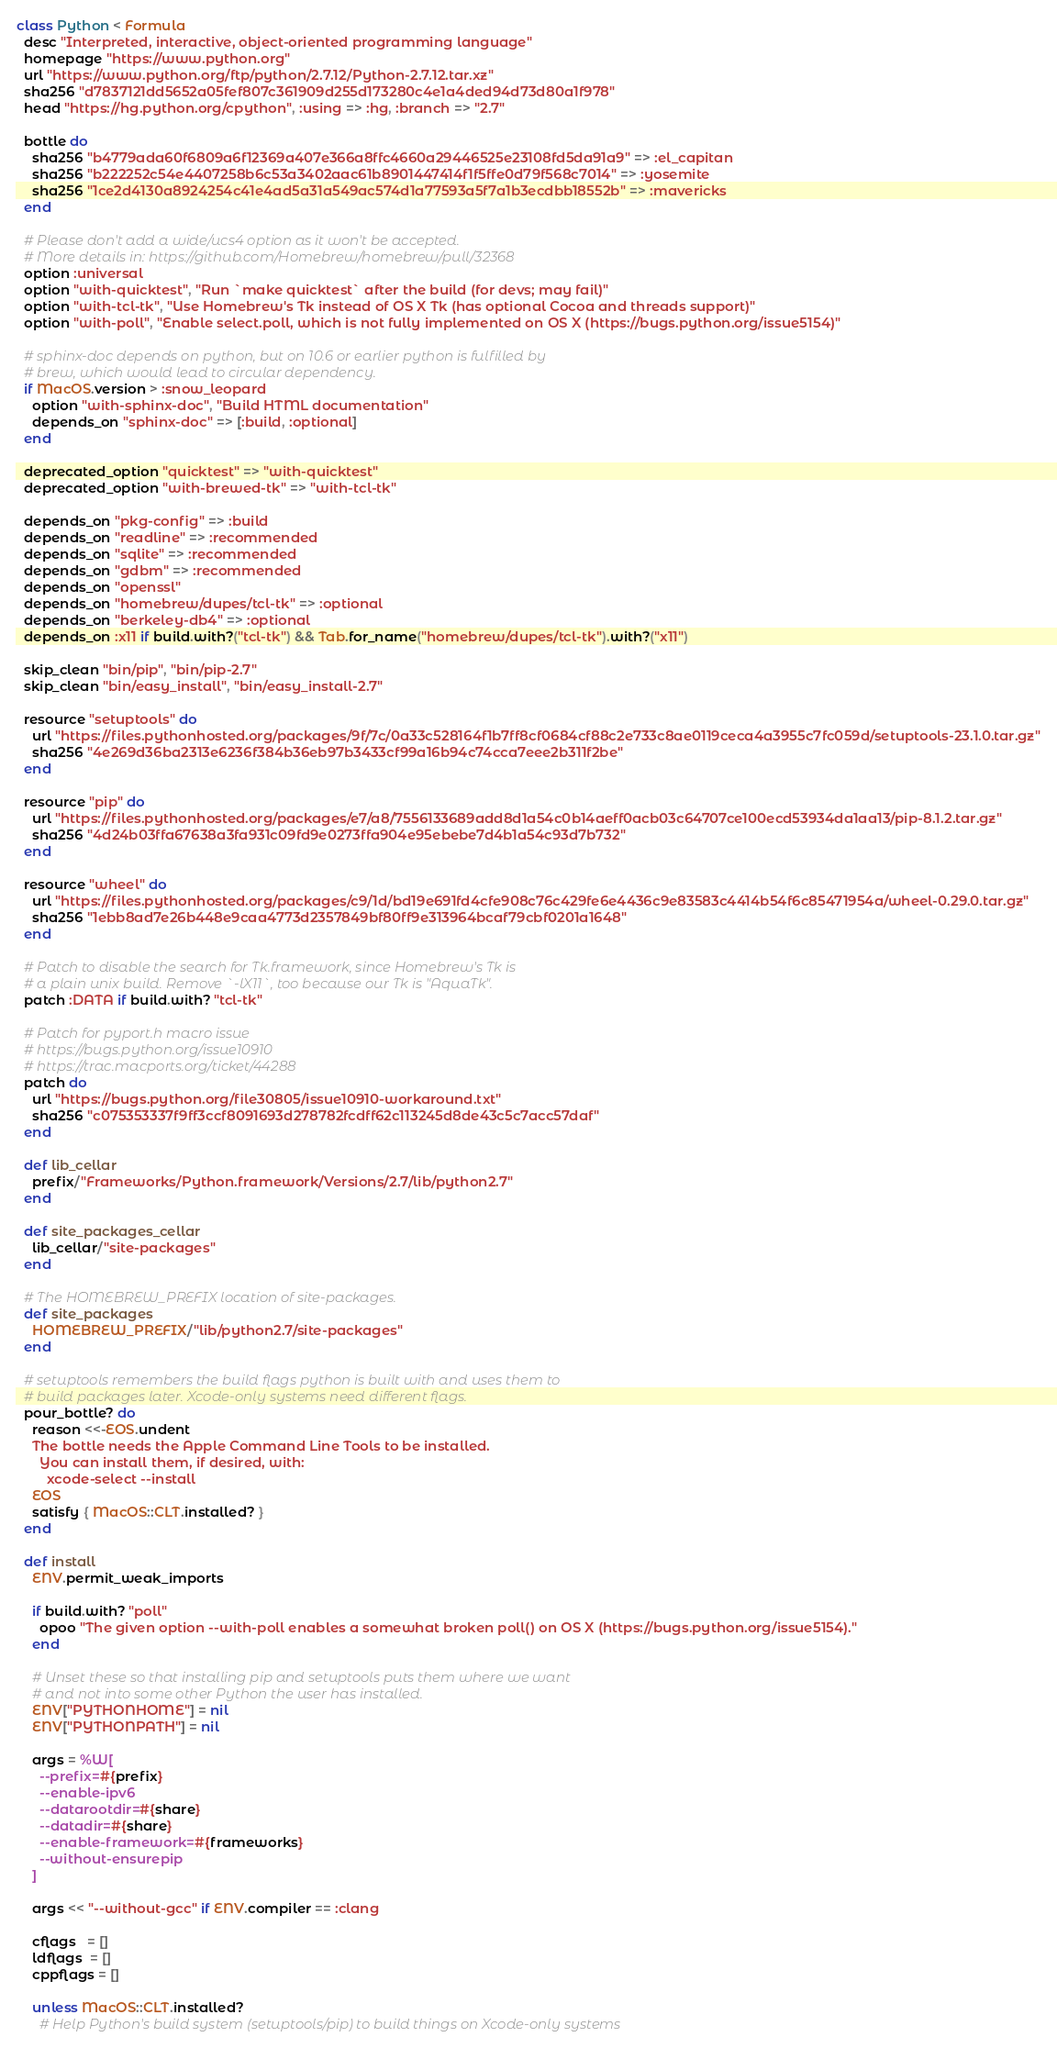Convert code to text. <code><loc_0><loc_0><loc_500><loc_500><_Ruby_>class Python < Formula
  desc "Interpreted, interactive, object-oriented programming language"
  homepage "https://www.python.org"
  url "https://www.python.org/ftp/python/2.7.12/Python-2.7.12.tar.xz"
  sha256 "d7837121dd5652a05fef807c361909d255d173280c4e1a4ded94d73d80a1f978"
  head "https://hg.python.org/cpython", :using => :hg, :branch => "2.7"

  bottle do
    sha256 "b4779ada60f6809a6f12369a407e366a8ffc4660a29446525e23108fd5da91a9" => :el_capitan
    sha256 "b222252c54e4407258b6c53a3402aac61b8901447414f1f5ffe0d79f568c7014" => :yosemite
    sha256 "1ce2d4130a8924254c41e4ad5a31a549ac574d1a77593a5f7a1b3ecdbb18552b" => :mavericks
  end

  # Please don't add a wide/ucs4 option as it won't be accepted.
  # More details in: https://github.com/Homebrew/homebrew/pull/32368
  option :universal
  option "with-quicktest", "Run `make quicktest` after the build (for devs; may fail)"
  option "with-tcl-tk", "Use Homebrew's Tk instead of OS X Tk (has optional Cocoa and threads support)"
  option "with-poll", "Enable select.poll, which is not fully implemented on OS X (https://bugs.python.org/issue5154)"

  # sphinx-doc depends on python, but on 10.6 or earlier python is fulfilled by
  # brew, which would lead to circular dependency.
  if MacOS.version > :snow_leopard
    option "with-sphinx-doc", "Build HTML documentation"
    depends_on "sphinx-doc" => [:build, :optional]
  end

  deprecated_option "quicktest" => "with-quicktest"
  deprecated_option "with-brewed-tk" => "with-tcl-tk"

  depends_on "pkg-config" => :build
  depends_on "readline" => :recommended
  depends_on "sqlite" => :recommended
  depends_on "gdbm" => :recommended
  depends_on "openssl"
  depends_on "homebrew/dupes/tcl-tk" => :optional
  depends_on "berkeley-db4" => :optional
  depends_on :x11 if build.with?("tcl-tk") && Tab.for_name("homebrew/dupes/tcl-tk").with?("x11")

  skip_clean "bin/pip", "bin/pip-2.7"
  skip_clean "bin/easy_install", "bin/easy_install-2.7"

  resource "setuptools" do
    url "https://files.pythonhosted.org/packages/9f/7c/0a33c528164f1b7ff8cf0684cf88c2e733c8ae0119ceca4a3955c7fc059d/setuptools-23.1.0.tar.gz"
    sha256 "4e269d36ba2313e6236f384b36eb97b3433cf99a16b94c74cca7eee2b311f2be"
  end

  resource "pip" do
    url "https://files.pythonhosted.org/packages/e7/a8/7556133689add8d1a54c0b14aeff0acb03c64707ce100ecd53934da1aa13/pip-8.1.2.tar.gz"
    sha256 "4d24b03ffa67638a3fa931c09fd9e0273ffa904e95ebebe7d4b1a54c93d7b732"
  end

  resource "wheel" do
    url "https://files.pythonhosted.org/packages/c9/1d/bd19e691fd4cfe908c76c429fe6e4436c9e83583c4414b54f6c85471954a/wheel-0.29.0.tar.gz"
    sha256 "1ebb8ad7e26b448e9caa4773d2357849bf80ff9e313964bcaf79cbf0201a1648"
  end

  # Patch to disable the search for Tk.framework, since Homebrew's Tk is
  # a plain unix build. Remove `-lX11`, too because our Tk is "AquaTk".
  patch :DATA if build.with? "tcl-tk"

  # Patch for pyport.h macro issue
  # https://bugs.python.org/issue10910
  # https://trac.macports.org/ticket/44288
  patch do
    url "https://bugs.python.org/file30805/issue10910-workaround.txt"
    sha256 "c075353337f9ff3ccf8091693d278782fcdff62c113245d8de43c5c7acc57daf"
  end

  def lib_cellar
    prefix/"Frameworks/Python.framework/Versions/2.7/lib/python2.7"
  end

  def site_packages_cellar
    lib_cellar/"site-packages"
  end

  # The HOMEBREW_PREFIX location of site-packages.
  def site_packages
    HOMEBREW_PREFIX/"lib/python2.7/site-packages"
  end

  # setuptools remembers the build flags python is built with and uses them to
  # build packages later. Xcode-only systems need different flags.
  pour_bottle? do
    reason <<-EOS.undent
    The bottle needs the Apple Command Line Tools to be installed.
      You can install them, if desired, with:
        xcode-select --install
    EOS
    satisfy { MacOS::CLT.installed? }
  end

  def install
    ENV.permit_weak_imports

    if build.with? "poll"
      opoo "The given option --with-poll enables a somewhat broken poll() on OS X (https://bugs.python.org/issue5154)."
    end

    # Unset these so that installing pip and setuptools puts them where we want
    # and not into some other Python the user has installed.
    ENV["PYTHONHOME"] = nil
    ENV["PYTHONPATH"] = nil

    args = %W[
      --prefix=#{prefix}
      --enable-ipv6
      --datarootdir=#{share}
      --datadir=#{share}
      --enable-framework=#{frameworks}
      --without-ensurepip
    ]

    args << "--without-gcc" if ENV.compiler == :clang

    cflags   = []
    ldflags  = []
    cppflags = []

    unless MacOS::CLT.installed?
      # Help Python's build system (setuptools/pip) to build things on Xcode-only systems</code> 